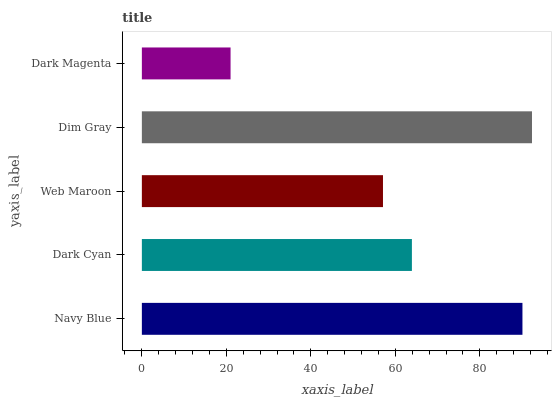Is Dark Magenta the minimum?
Answer yes or no. Yes. Is Dim Gray the maximum?
Answer yes or no. Yes. Is Dark Cyan the minimum?
Answer yes or no. No. Is Dark Cyan the maximum?
Answer yes or no. No. Is Navy Blue greater than Dark Cyan?
Answer yes or no. Yes. Is Dark Cyan less than Navy Blue?
Answer yes or no. Yes. Is Dark Cyan greater than Navy Blue?
Answer yes or no. No. Is Navy Blue less than Dark Cyan?
Answer yes or no. No. Is Dark Cyan the high median?
Answer yes or no. Yes. Is Dark Cyan the low median?
Answer yes or no. Yes. Is Navy Blue the high median?
Answer yes or no. No. Is Web Maroon the low median?
Answer yes or no. No. 